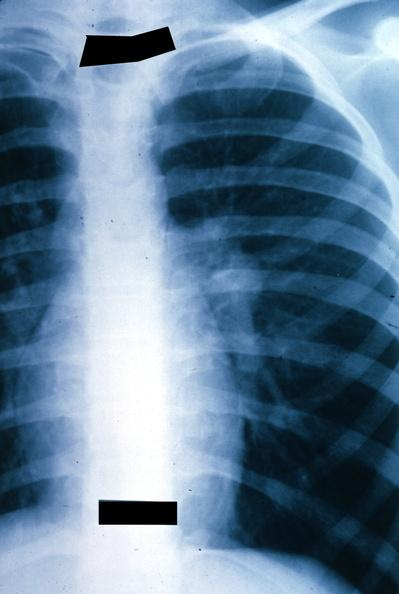where is this?
Answer the question using a single word or phrase. Lung 